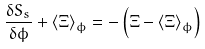Convert formula to latex. <formula><loc_0><loc_0><loc_500><loc_500>\frac { \delta S _ { s } } { \delta \phi } + \left \langle \Xi \right \rangle _ { \phi } = - \left ( \Xi - \left \langle \Xi \right \rangle _ { \phi } \right )</formula> 